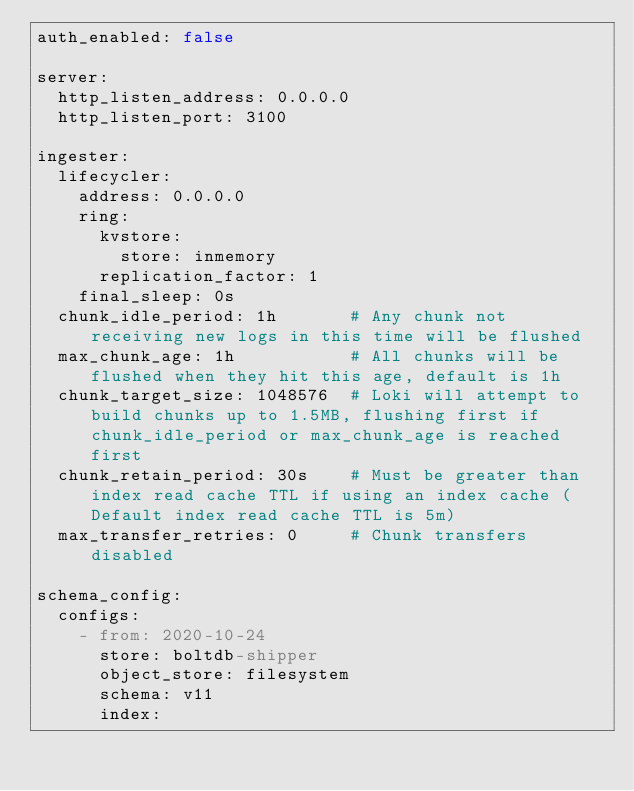Convert code to text. <code><loc_0><loc_0><loc_500><loc_500><_YAML_>auth_enabled: false

server:
  http_listen_address: 0.0.0.0
  http_listen_port: 3100

ingester:
  lifecycler:
    address: 0.0.0.0
    ring:
      kvstore:
        store: inmemory
      replication_factor: 1
    final_sleep: 0s
  chunk_idle_period: 1h       # Any chunk not receiving new logs in this time will be flushed
  max_chunk_age: 1h           # All chunks will be flushed when they hit this age, default is 1h
  chunk_target_size: 1048576  # Loki will attempt to build chunks up to 1.5MB, flushing first if chunk_idle_period or max_chunk_age is reached first
  chunk_retain_period: 30s    # Must be greater than index read cache TTL if using an index cache (Default index read cache TTL is 5m)
  max_transfer_retries: 0     # Chunk transfers disabled

schema_config:
  configs:
    - from: 2020-10-24
      store: boltdb-shipper
      object_store: filesystem
      schema: v11
      index:</code> 